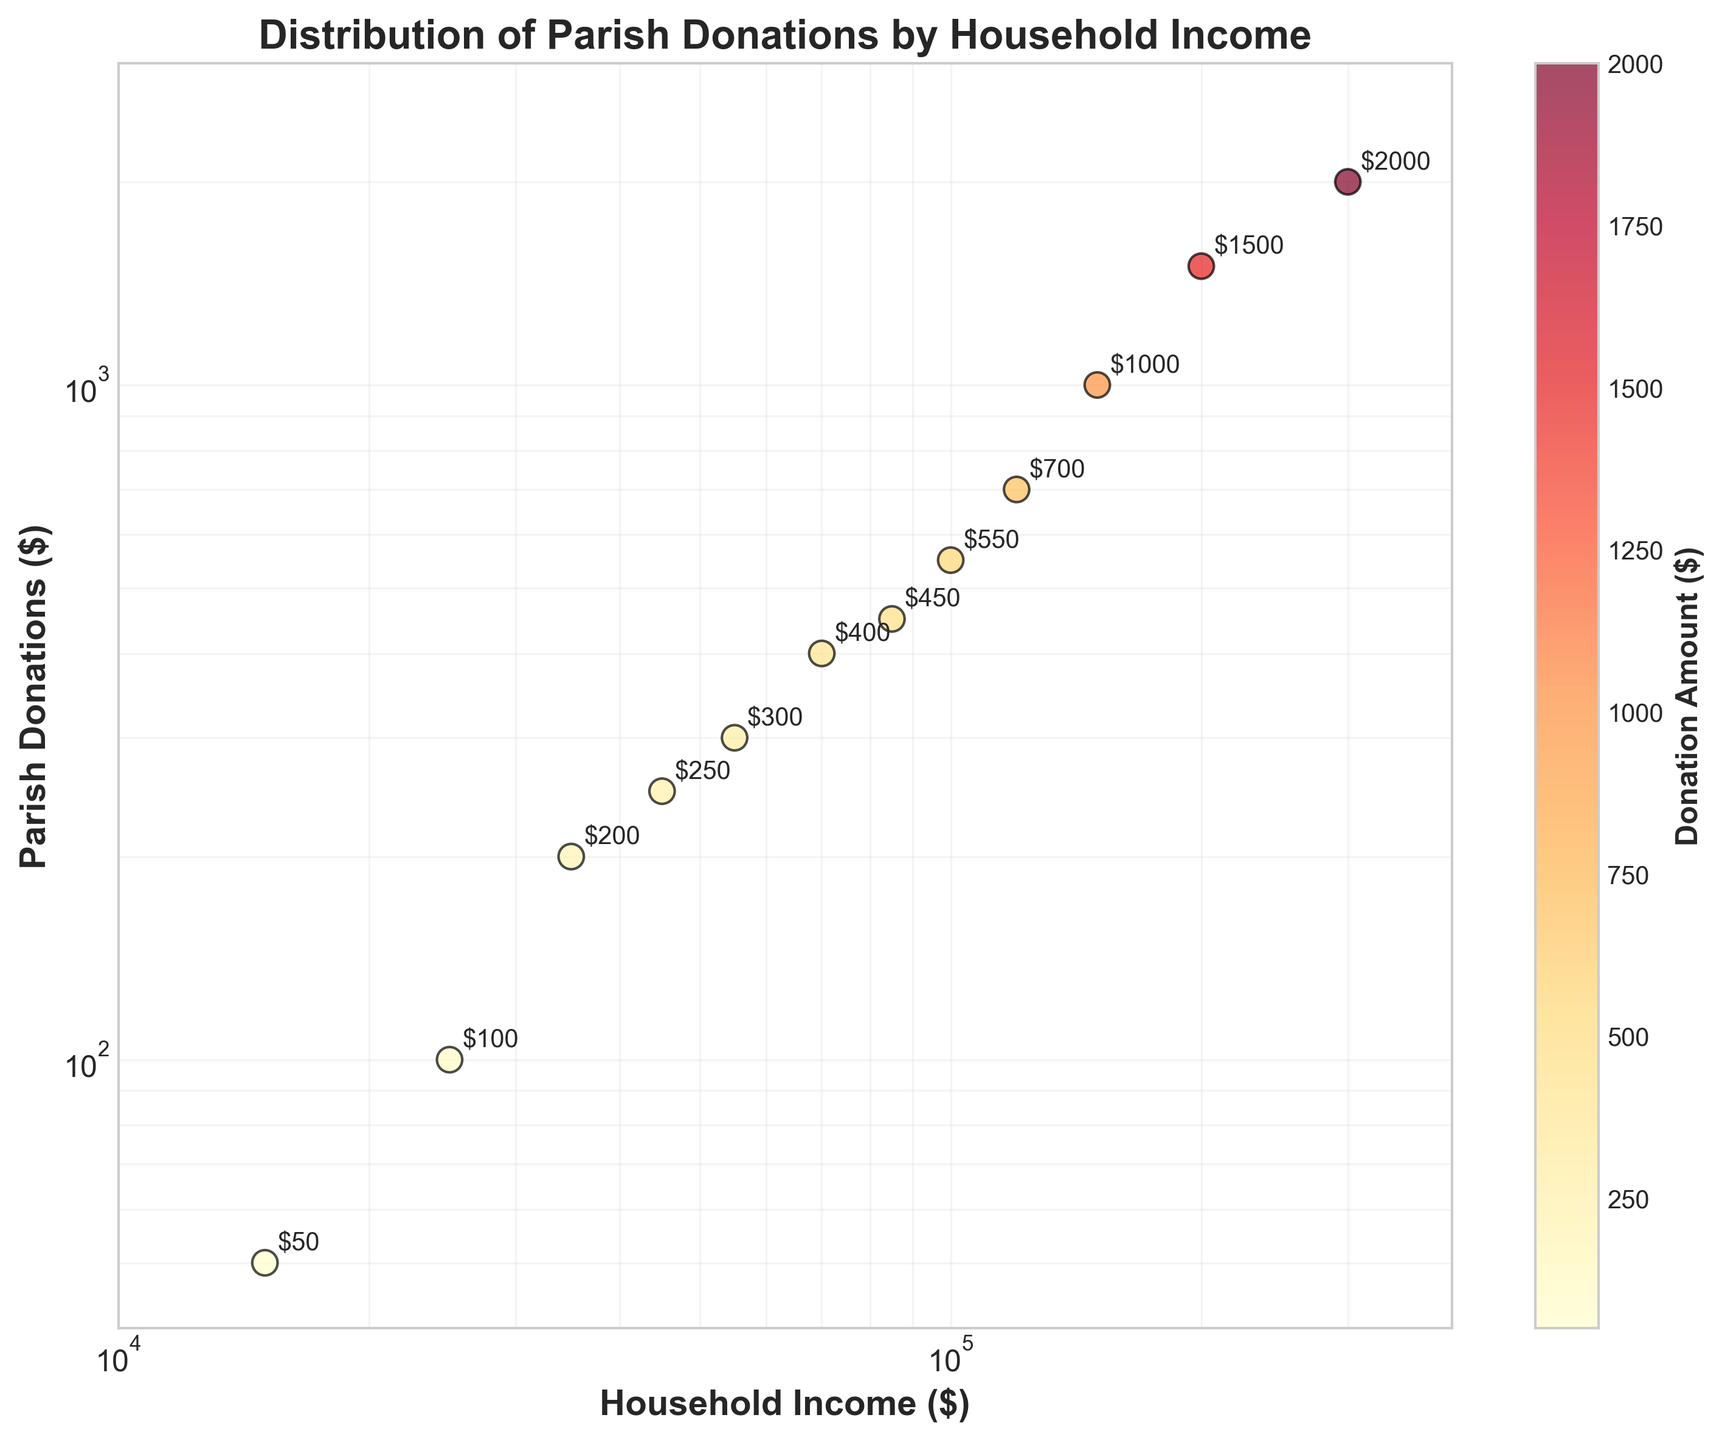What is the title of the figure? The title of the figure is located at the top and is bolded. It indicates the main topic or theme being visualized in the plot.
Answer: Distribution of Parish Donations by Household Income How many data points are plotted in the figure? The data points can be counted by looking at the number of markers (dots) on the scatter plot. Each marker represents a single data entry from the dataset.
Answer: 12 What is the x-axis labeled as? The x-axis is labeled to describe what the horizontal axis represents. The label can usually be found near or on the axis line itself.
Answer: Household Income ($) What is the donation amount for a household income of $120,000? Locate the point where the household income is $120,000 on the x-axis. From that point, trace vertically to find the corresponding donation amount on the y-axis.
Answer: $700 Which household income has the highest donation amount, and what is it? To find the highest donation, look for the data point that is highest on the y-axis. Then, trace horizontally to find the corresponding household income.
Answer: $300,000, $2000 What is the range of the household income axis on the figure? The range of the x-axis can be determined by looking at the smallest and largest values shown on the axis.
Answer: $10,000 to $400,000 Is there a general trend between household income and parish donations? Observe the overall pattern of the data points to determine if there is an increasing or decreasing trend as the x-axis values change.
Answer: Generally, as household income increases, parish donations also increase What is the color indicating in the plot, and how is it represented? The color of the points in the scatter plot represents another variable. In this plot, it denotes the donation amount. This representation can be confirmed by decoding the color bar.
Answer: Donation amount, color bar For household incomes of $150,000 and $200,000, what is the difference in parish donations? Find the donation amounts for $150,000 and $200,000 household incomes and subtract the smaller amount from the larger amount to find the difference.
Answer: $500 Which household income-donation pair lies closest to the lower boundary of the y-axis? Identify the data point nearest to the bottom of the y-axis and then determine the corresponding household income.
Answer: $15,000, $50 Explain the significance of the log scale used for both axes in the scatter plot. A log scale is used to handle a wide range of values more effectively by compressing larger values and expanding smaller values. This helps in visualizing the data more clearly and identifying patterns or trends that might not be obvious on a linear scale.
Answer: Enhances data visualization across wide value ranges 